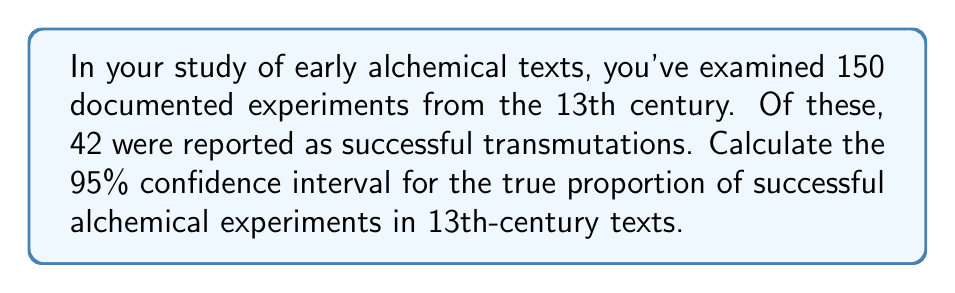Can you solve this math problem? Let's approach this step-by-step:

1) First, we need to calculate the sample proportion $\hat{p}$:
   $$\hat{p} = \frac{\text{number of successes}}{\text{total number of experiments}} = \frac{42}{150} = 0.28$$

2) For a 95% confidence interval, we use a z-score of 1.96.

3) The formula for the confidence interval is:
   $$\hat{p} \pm z\sqrt{\frac{\hat{p}(1-\hat{p})}{n}}$$

4) Let's calculate the standard error:
   $$SE = \sqrt{\frac{\hat{p}(1-\hat{p})}{n}} = \sqrt{\frac{0.28(1-0.28)}{150}} = \sqrt{\frac{0.2016}{150}} \approx 0.0367$$

5) Now we can calculate the margin of error:
   $$ME = 1.96 \times 0.0367 \approx 0.0719$$

6) Therefore, our confidence interval is:
   $$0.28 \pm 0.0719$$

7) This gives us a lower bound of $0.28 - 0.0719 = 0.2081$ and an upper bound of $0.28 + 0.0719 = 0.3519$.
Answer: (0.2081, 0.3519) 